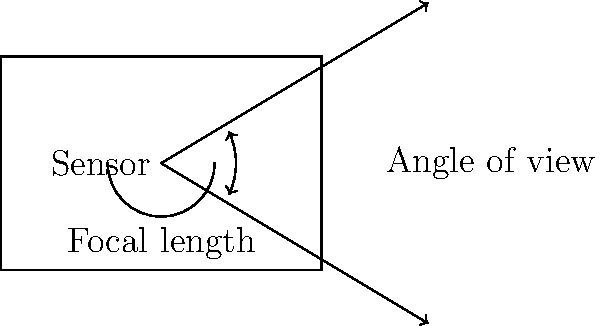As a neighborhood photographer, you're using a wide-angle lens with a focal length of 24mm on a full-frame camera with a sensor size of 36mm x 24mm. Calculate the horizontal angle of view for this setup. To calculate the horizontal angle of view, we'll use the following steps:

1. Recall the formula for angle of view:
   $$\text{Angle of View} = 2 \times \arctan\left(\frac{\text{Sensor dimension}}{2 \times \text{Focal length}}\right)$$

2. Identify the known values:
   - Focal length (f) = 24mm
   - Sensor width (horizontal dimension) = 36mm

3. Substitute these values into the formula:
   $$\text{Angle of View} = 2 \times \arctan\left(\frac{36\text{ mm}}{2 \times 24\text{ mm}}\right)$$

4. Simplify:
   $$\text{Angle of View} = 2 \times \arctan\left(\frac{36}{48}\right)$$
   $$\text{Angle of View} = 2 \times \arctan(0.75)$$

5. Calculate the arctangent:
   $$\text{Angle of View} = 2 \times 36.87°$$

6. Multiply by 2:
   $$\text{Angle of View} = 73.74°$$

Therefore, the horizontal angle of view for this wide-angle lens setup is approximately 73.74°.
Answer: 73.74° 